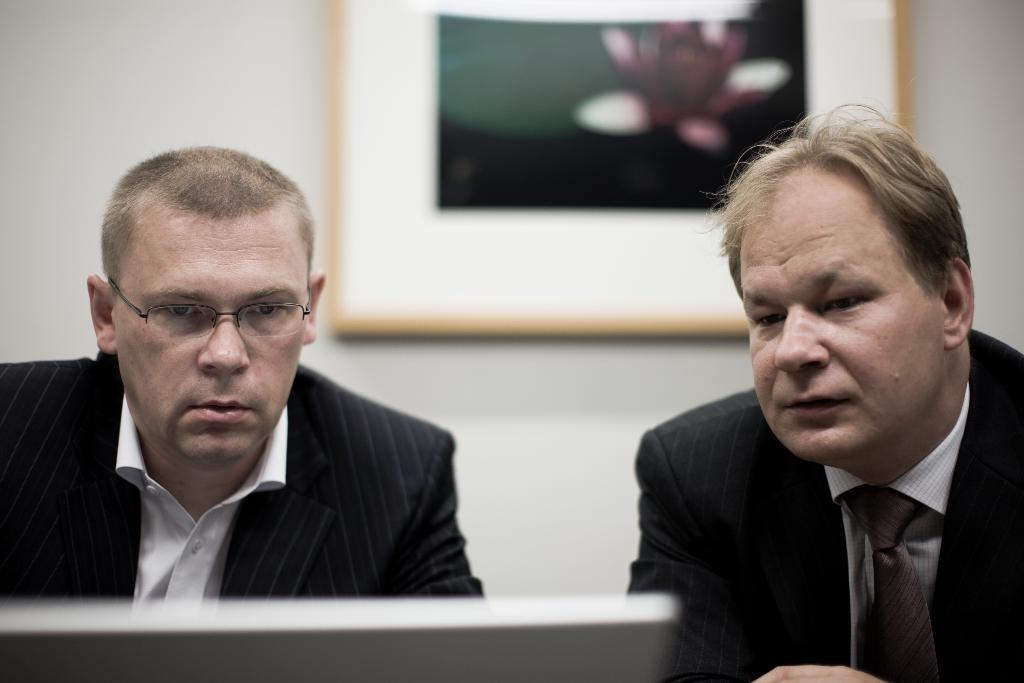Describe this image in one or two sentences. In this image I can see 2 people sitting, wearing suit. There is a screen in front of them. There is a photo frame on a wall, at the back. 